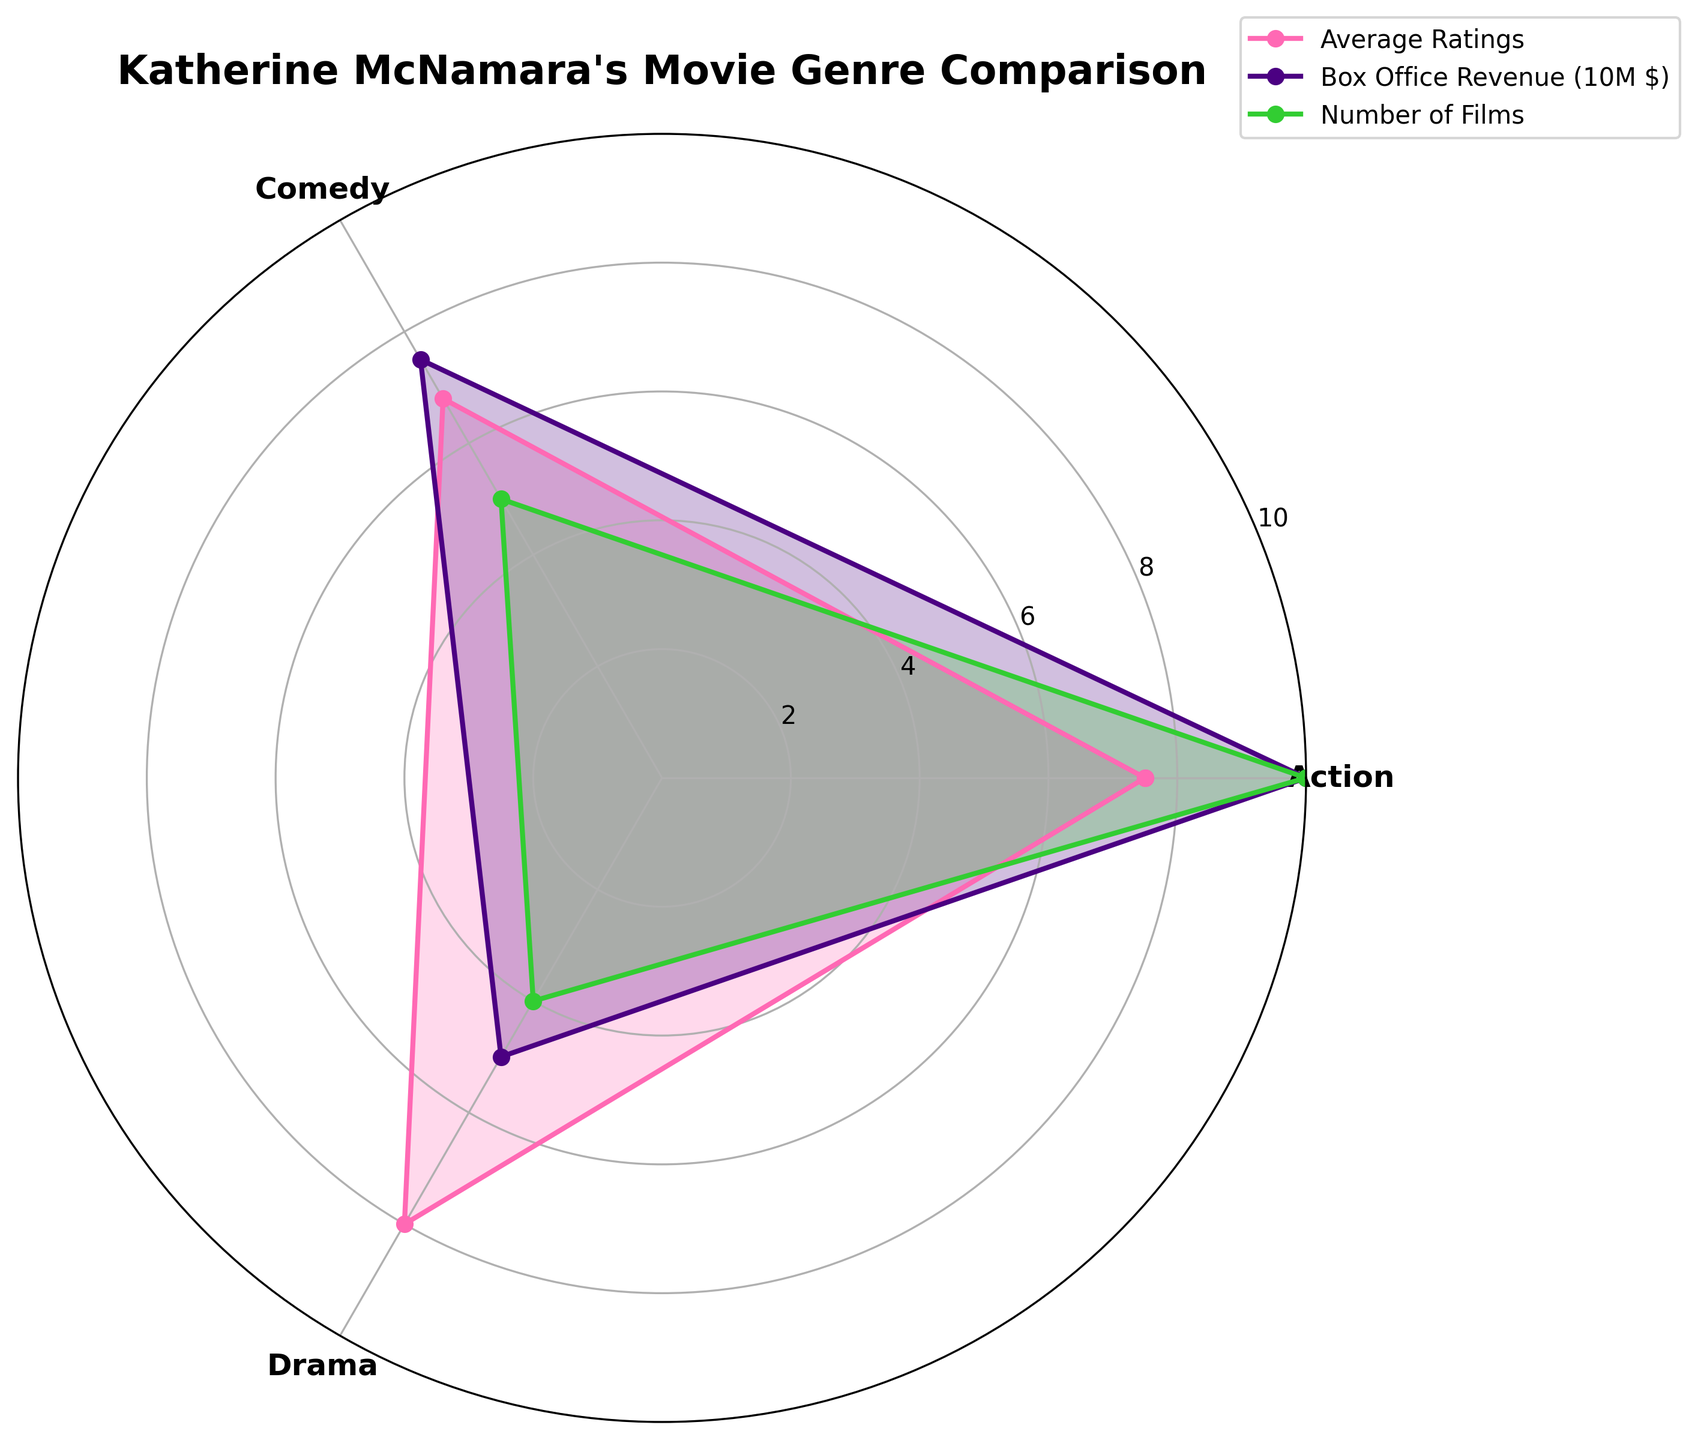What's the title of the radar chart? The title of the radar chart can be found at the top of the figure. It summarizes the content of the chart.
Answer: Katherine McNamara's Movie Genre Comparison What color is used to represent the 'Average Ratings' in the radar chart? The radar chart uses different colors to distinguish between various categories. The color used for 'Average Ratings' can be identified by observing the plot lines and filled areas.
Answer: Pink Which movie genre has the highest average rating? To determine the genre with the highest average rating, you need to look at the peak of the 'Average Ratings' line on the radar chart. The genre at the angle with the highest value on the pink line is the one with the highest average rating.
Answer: Drama Compare the number of films in Action and Comedy genres. Which has more? By observing the green lines representing 'Number of Films,' you can compare the values for the Action and Comedy genres. The genre with the higher number on the green axis has more films.
Answer: Action What is the difference in box office revenue between Drama and Comedy genres (in millions of dollars)? The purple line represents Box Office Revenue. Compare the values for Drama and Comedy, and then subtract the Comedy value from the Drama value to get the difference.
Answer: -25 million dollars How many genres are being compared in the radar chart? Count the distinct categories or sections on the radar chart. Each category represents a genre being compared.
Answer: 3 Which genre has the lowest number of films? Look at the green line indicating 'Number of Films' and identify the point with the lowest value, then check which genre this corresponds to.
Answer: Drama Of the Average Ratings provided, what is the median value? List the ratings in numerical order and find the middle value. The ratings are 6.8, 7.5, and 8.0.
Answer: 7.5 Does the box office revenue line intersect with the average ratings line for any genre? Visually check whether the pink line (Average Ratings) intersects with the purple line (Box Office Revenue) at any of the genre angles on the radar chart.
Answer: No What is the ratio of the number of films between Action and Drama genres? Divide the number of films in the Action genre by the number of films in the Drama genre. Action has 10 films and Drama has 4 films. So, the ratio is 10/4.
Answer: 2.5 